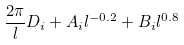Convert formula to latex. <formula><loc_0><loc_0><loc_500><loc_500>\frac { 2 \pi } { l } D _ { i } + A _ { i } l ^ { - 0 . 2 } + B _ { i } l ^ { 0 . 8 }</formula> 